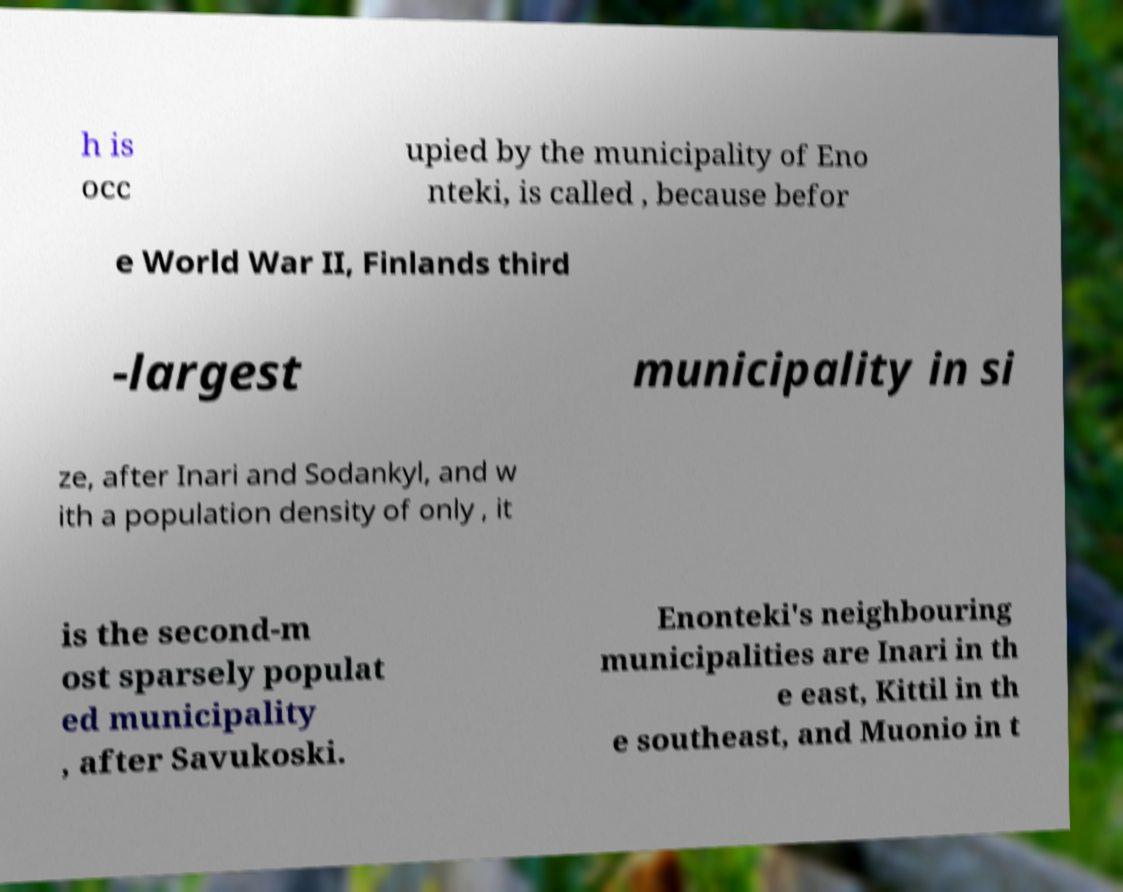There's text embedded in this image that I need extracted. Can you transcribe it verbatim? h is occ upied by the municipality of Eno nteki, is called , because befor e World War II, Finlands third -largest municipality in si ze, after Inari and Sodankyl, and w ith a population density of only , it is the second-m ost sparsely populat ed municipality , after Savukoski. Enonteki's neighbouring municipalities are Inari in th e east, Kittil in th e southeast, and Muonio in t 